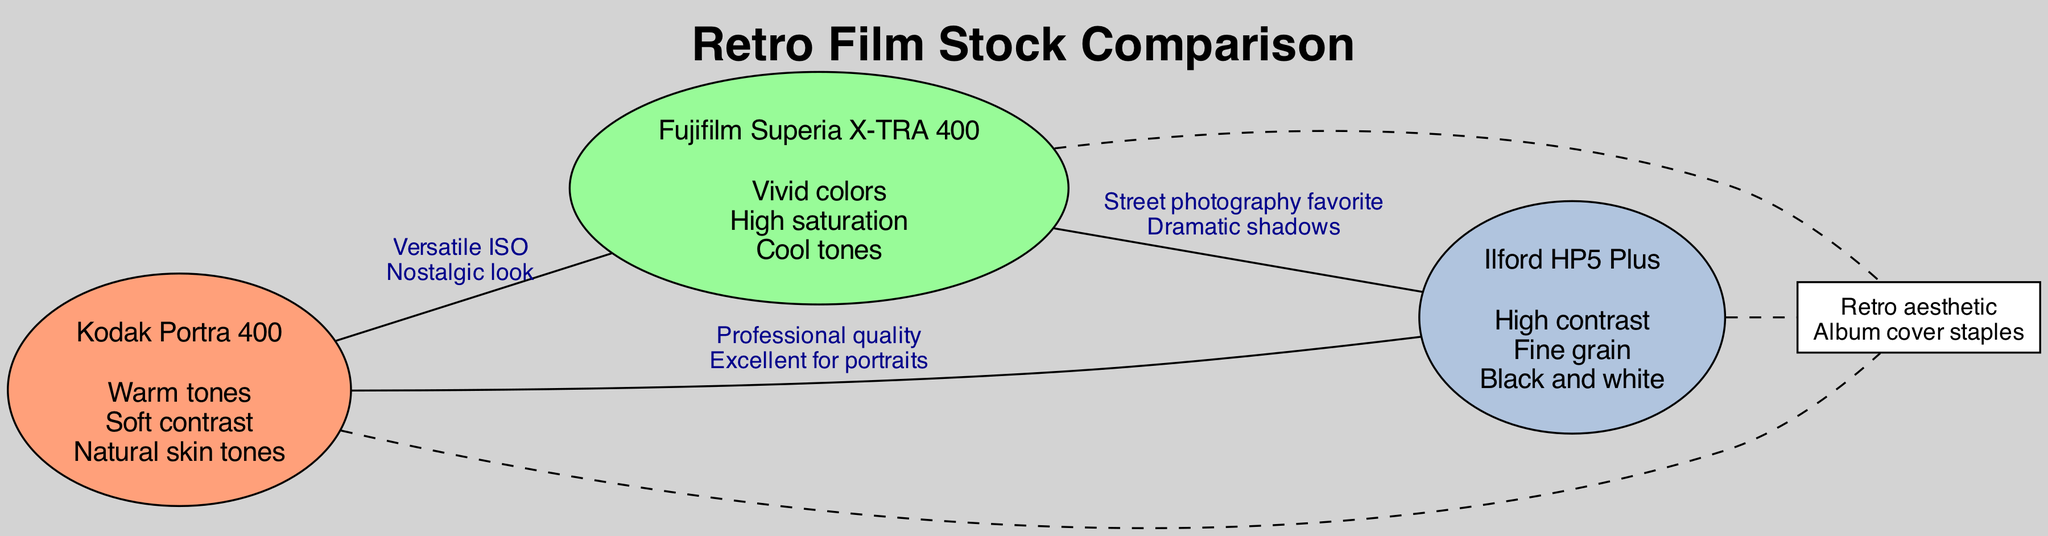What are the elements in Kodak Portra 400? The diagram lists the elements of Kodak Portra 400 directly within its node. It states "Warm tones, Soft contrast, Natural skin tones."
Answer: Warm tones, Soft contrast, Natural skin tones How many elements are associated with Ilford HP5 Plus? The node for Ilford HP5 Plus contains three elements. By counting the listed elements, they are "High contrast, Fine grain, Black and white."
Answer: 3 What color tone is emphasized by Fujifilm Superia X-TRA 400? The elements listed under Fujifilm Superia X-TRA 400 include "Vivid colors, High saturation, Cool tones," indicating it emphasizes cool tones.
Answer: Cool tones What do Kodak Portra 400 and Ilford HP5 Plus have in common? In the intersection between Kodak Portra 400 and Ilford HP5 Plus, the shared elements are "Professional quality, Excellent for portraits," showing they both are known for these qualities.
Answer: Professional quality, Excellent for portraits Which film stocks share the characteristic of a "Retro aesthetic"? The intersection among all three sets (Kodak Portra 400, Fujifilm Superia X-TRA 400, Ilford HP5 Plus) states "Retro aesthetic" as a common element listed in that central intersection node.
Answer: Retro aesthetic Which film stock is described as a “Street photography favorite”? The intersection between Fujifilm Superia X-TRA 400 and Ilford HP5 Plus lists "Street photography favorite" as a shared characteristic, indicating that this quality is attributed to these two film stocks.
Answer: Fujifilm Superia X-TRA 400 and Ilford HP5 Plus How many unique film stocks are represented in the diagram? The diagram contains three distinct film stocks: Kodak Portra 400, Fujifilm Superia X-TRA 400, and Ilford HP5 Plus. Therefore, the total count is three.
Answer: 3 What element is shared among all three film stocks? The diagram indicates that the central intersection node contains "Retro aesthetic, Album cover staples," which are common elements found in all three film stocks.
Answer: Retro aesthetic, Album cover staples 